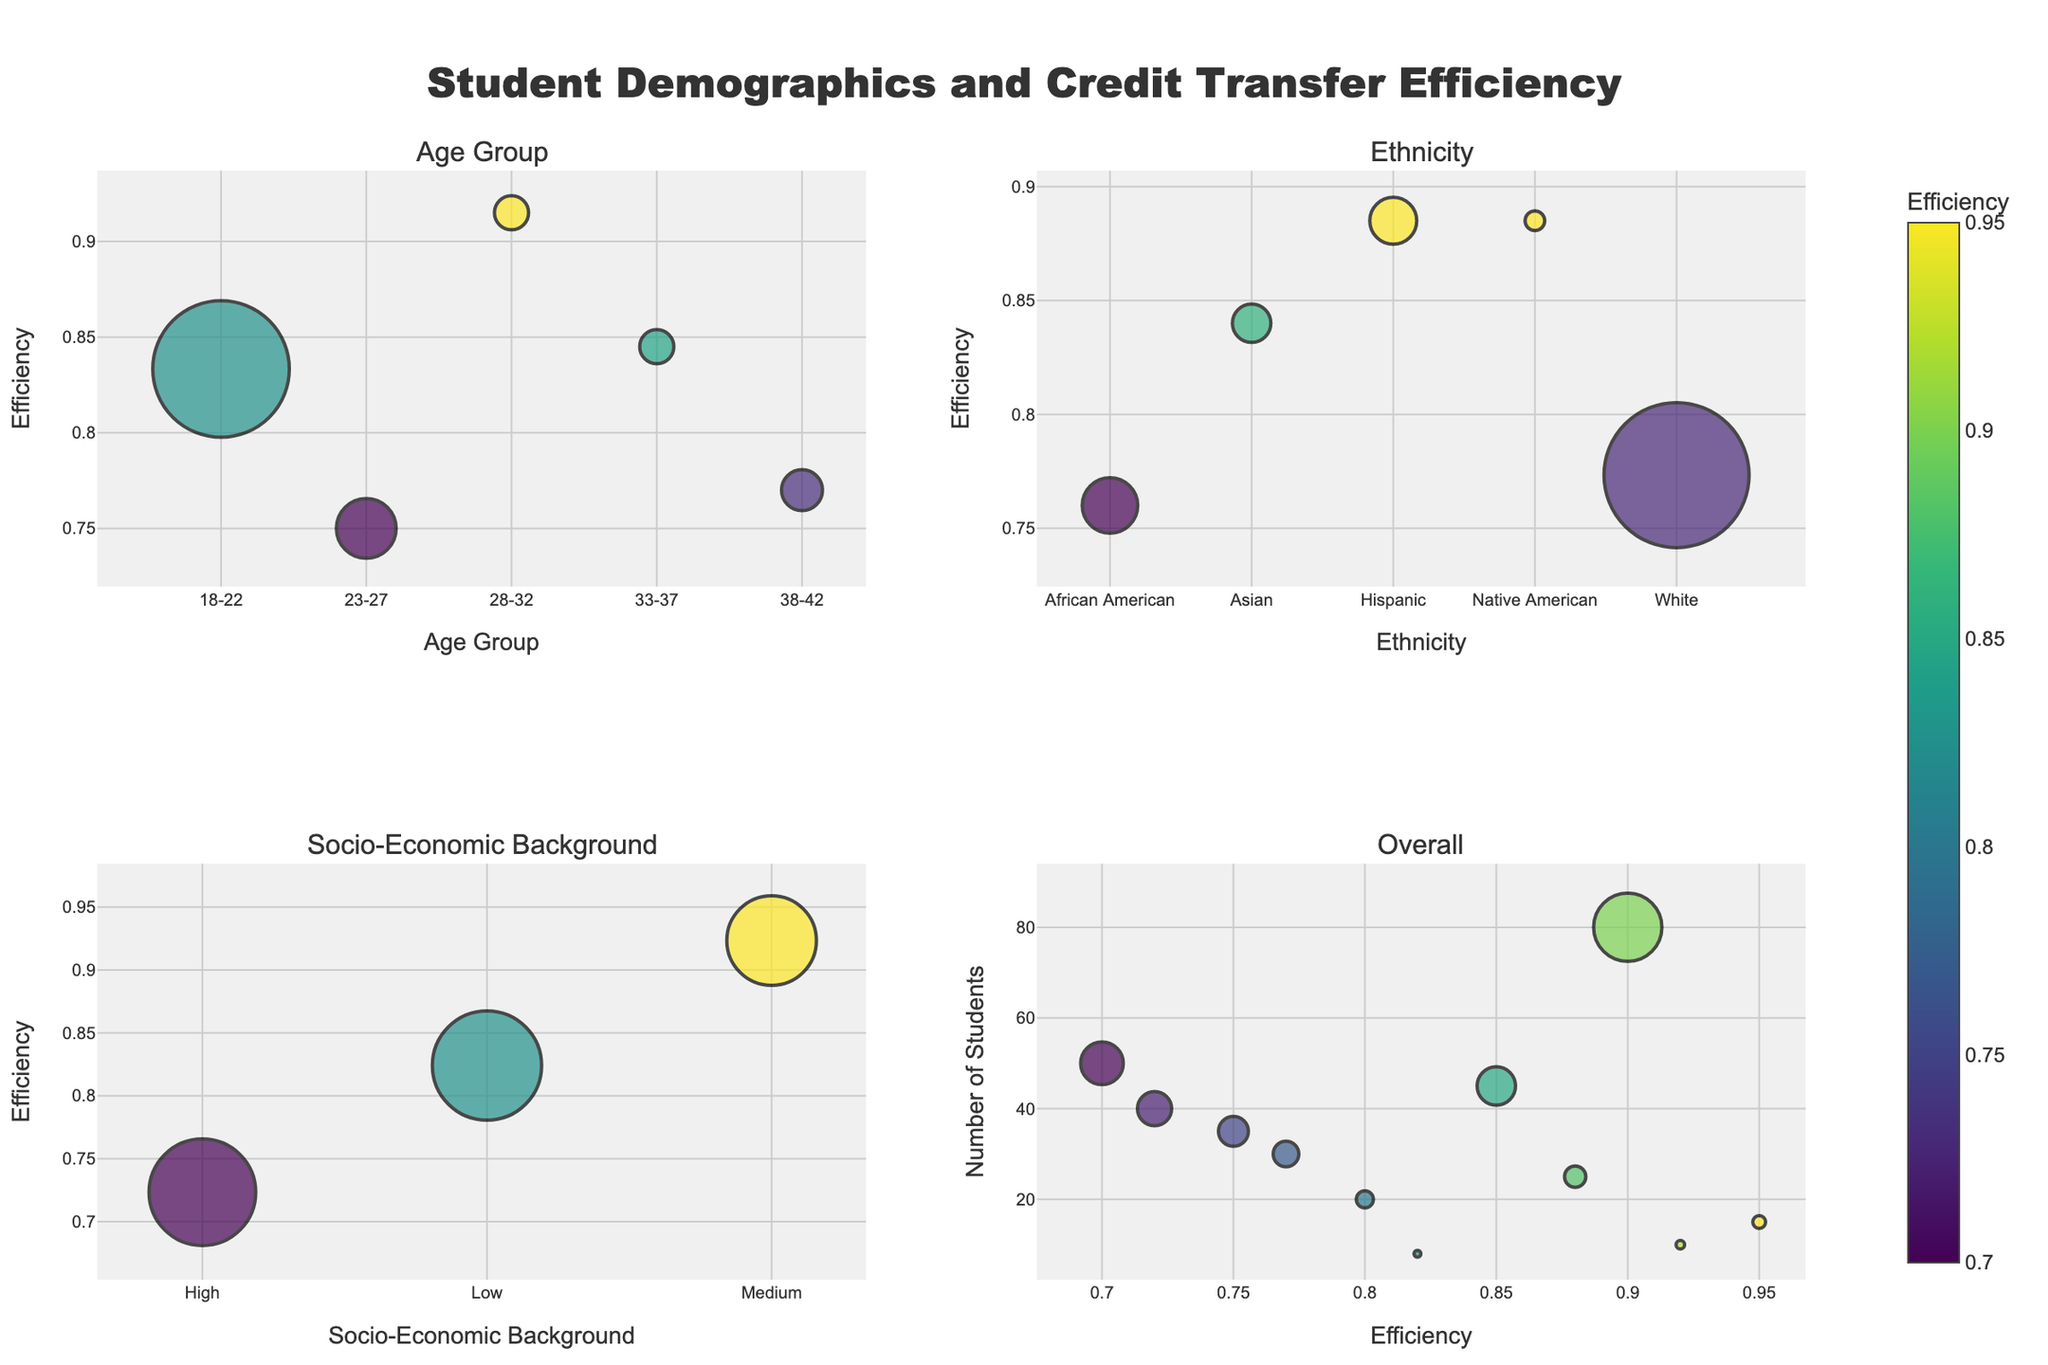What age group has the highest credit transfer efficiency? The efficiency is highest for the 28-32 age group. This can be observed from the age group subplot where the point representing 28-32 is the highest on the y-axis.
Answer: 28-32 Which ethnicity has the lowest overall credit transfer efficiency? From the ethnicity subplot, the lowest point on the y-axis represents African American students.
Answer: African American How does the socio-economic background of students relate to credit transfer efficiency? The socio-economic subplot shows that students from a medium background have the highest efficiency, followed by low, and then high backgrounds. This can be observed from the vertical positions of the points.
Answer: Medium > Low > High What is the credit transfer efficiency for the 23-27 age group based on students' socio-economic background? By looking at the overall subplot and filtering based on the 23-27 age group and socio-economic backgrounds, we can see that low background students have an efficiency of 0.80 and high background students have 0.70.
Answer: Low: 0.80, High: 0.70 Which age group has the most significant number of students and what is their credit transfer efficiency? The largest bubble in the age group subplot represents the 18-22 age group, indicating they have the most students. Their efficiency is around 0.85.
Answer: 18-22, 0.85 Compare the credit transfer efficiencies between Asian students in the 23-27 and 28-32 age groups. From the overall subplot, filtering by Asian ethnicity, we see that the 23-27 age group has an efficiency of 0.80, whereas the 28-32 age group has 0.88.
Answer: 23-27: 0.80, 28-32: 0.88 Which factor appears to have the most significant variation in credit transfer efficiency? By examining the range and spread of efficiencies across the different subplots (age group, ethnicity, socio-economic background), socio-economic background shows the most significant variation, ranging from about 0.70 to 0.95.
Answer: Socio-Economic Background What is the efficiency range for Hispanic students? In the overall subplot, the efficiency values for Hispanic students (18-22 and 33-37) can be observed, and it ranges from 0.85 to 0.92.
Answer: 0.85 - 0.92 Which group has the smallest number of students and what are their demographics? From the overall subplot, the smallest bubble corresponds to Native American students aged 38-42 with a low socio-economic background.
Answer: Native American, 38-42, Low What is the pattern of credit transfer efficiency for White students across different age groups? By observing the overall subplot-filtered for White ethnicity, we can see the efficiencies for 18-22, 23-27, and 38-42 age groups are around 0.90, 0.70, and 0.72, respectively, indicating a decline from younger to older age groups.
Answer: 18-22: 0.90, 23-27: 0.70, 38-42: 0.72 